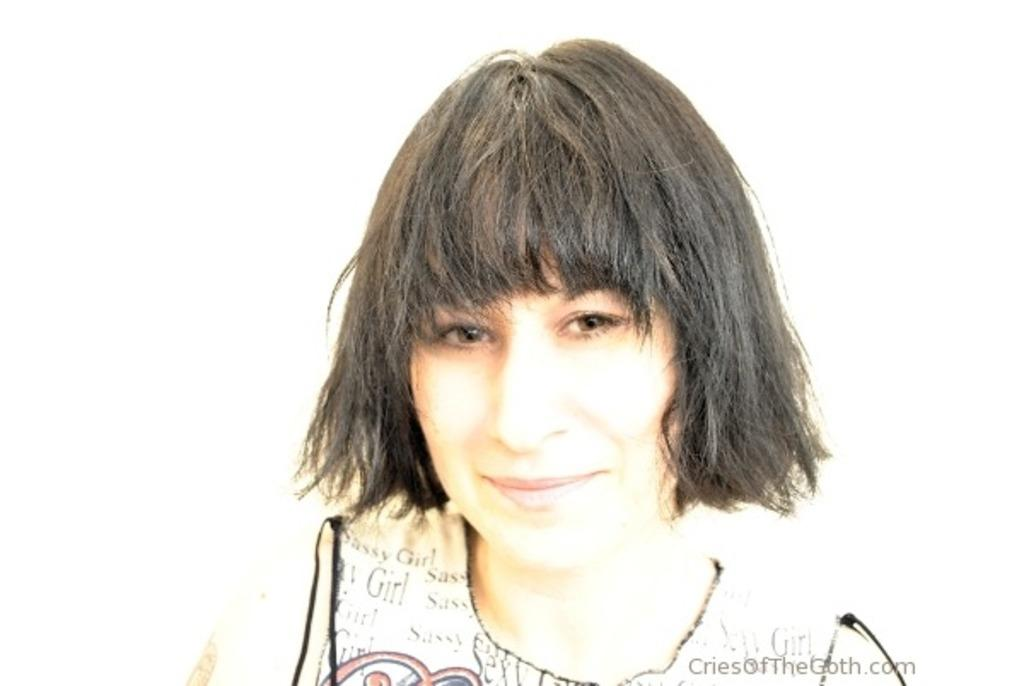Who is the main subject in the image? There is a woman in the center of the image. What is the woman doing in the image? The woman is smiling. What color is the background of the image? The background of the image is white. Where is the text located in the image? The text is in the bottom right corner of the image. How many babies are sitting on the copper seat in the image? There are no babies or copper seats present in the image. 